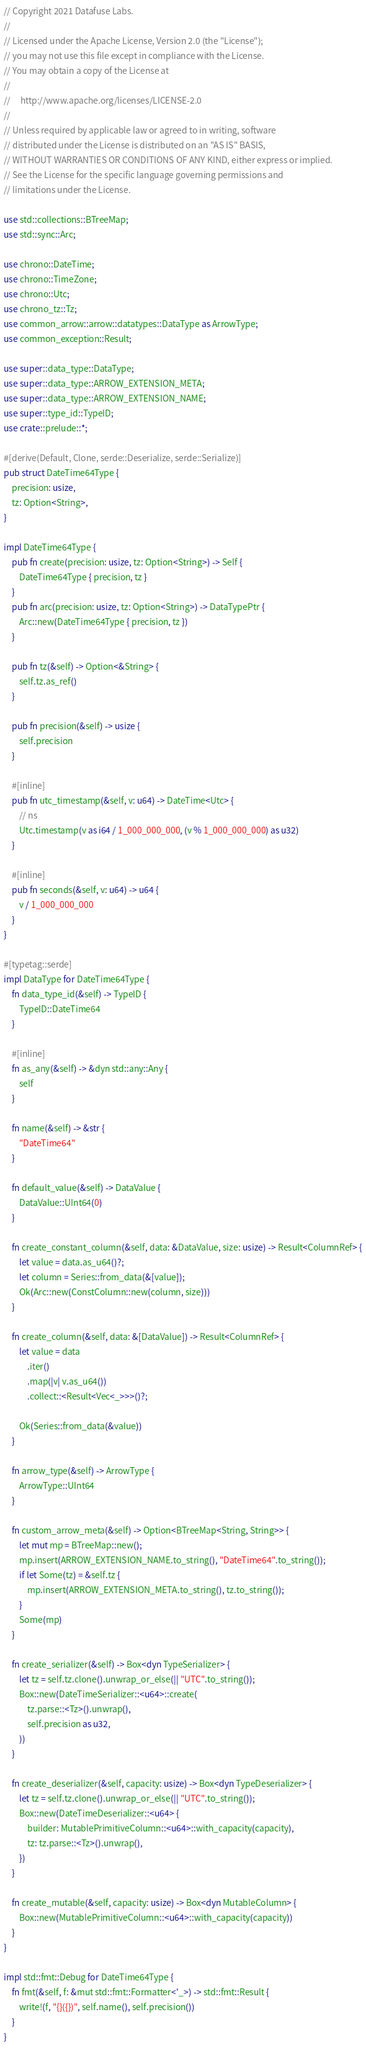<code> <loc_0><loc_0><loc_500><loc_500><_Rust_>// Copyright 2021 Datafuse Labs.
//
// Licensed under the Apache License, Version 2.0 (the "License");
// you may not use this file except in compliance with the License.
// You may obtain a copy of the License at
//
//     http://www.apache.org/licenses/LICENSE-2.0
//
// Unless required by applicable law or agreed to in writing, software
// distributed under the License is distributed on an "AS IS" BASIS,
// WITHOUT WARRANTIES OR CONDITIONS OF ANY KIND, either express or implied.
// See the License for the specific language governing permissions and
// limitations under the License.

use std::collections::BTreeMap;
use std::sync::Arc;

use chrono::DateTime;
use chrono::TimeZone;
use chrono::Utc;
use chrono_tz::Tz;
use common_arrow::arrow::datatypes::DataType as ArrowType;
use common_exception::Result;

use super::data_type::DataType;
use super::data_type::ARROW_EXTENSION_META;
use super::data_type::ARROW_EXTENSION_NAME;
use super::type_id::TypeID;
use crate::prelude::*;

#[derive(Default, Clone, serde::Deserialize, serde::Serialize)]
pub struct DateTime64Type {
    precision: usize,
    tz: Option<String>,
}

impl DateTime64Type {
    pub fn create(precision: usize, tz: Option<String>) -> Self {
        DateTime64Type { precision, tz }
    }
    pub fn arc(precision: usize, tz: Option<String>) -> DataTypePtr {
        Arc::new(DateTime64Type { precision, tz })
    }

    pub fn tz(&self) -> Option<&String> {
        self.tz.as_ref()
    }

    pub fn precision(&self) -> usize {
        self.precision
    }

    #[inline]
    pub fn utc_timestamp(&self, v: u64) -> DateTime<Utc> {
        // ns
        Utc.timestamp(v as i64 / 1_000_000_000, (v % 1_000_000_000) as u32)
    }

    #[inline]
    pub fn seconds(&self, v: u64) -> u64 {
        v / 1_000_000_000
    }
}

#[typetag::serde]
impl DataType for DateTime64Type {
    fn data_type_id(&self) -> TypeID {
        TypeID::DateTime64
    }

    #[inline]
    fn as_any(&self) -> &dyn std::any::Any {
        self
    }

    fn name(&self) -> &str {
        "DateTime64"
    }

    fn default_value(&self) -> DataValue {
        DataValue::UInt64(0)
    }

    fn create_constant_column(&self, data: &DataValue, size: usize) -> Result<ColumnRef> {
        let value = data.as_u64()?;
        let column = Series::from_data(&[value]);
        Ok(Arc::new(ConstColumn::new(column, size)))
    }

    fn create_column(&self, data: &[DataValue]) -> Result<ColumnRef> {
        let value = data
            .iter()
            .map(|v| v.as_u64())
            .collect::<Result<Vec<_>>>()?;

        Ok(Series::from_data(&value))
    }

    fn arrow_type(&self) -> ArrowType {
        ArrowType::UInt64
    }

    fn custom_arrow_meta(&self) -> Option<BTreeMap<String, String>> {
        let mut mp = BTreeMap::new();
        mp.insert(ARROW_EXTENSION_NAME.to_string(), "DateTime64".to_string());
        if let Some(tz) = &self.tz {
            mp.insert(ARROW_EXTENSION_META.to_string(), tz.to_string());
        }
        Some(mp)
    }

    fn create_serializer(&self) -> Box<dyn TypeSerializer> {
        let tz = self.tz.clone().unwrap_or_else(|| "UTC".to_string());
        Box::new(DateTimeSerializer::<u64>::create(
            tz.parse::<Tz>().unwrap(),
            self.precision as u32,
        ))
    }

    fn create_deserializer(&self, capacity: usize) -> Box<dyn TypeDeserializer> {
        let tz = self.tz.clone().unwrap_or_else(|| "UTC".to_string());
        Box::new(DateTimeDeserializer::<u64> {
            builder: MutablePrimitiveColumn::<u64>::with_capacity(capacity),
            tz: tz.parse::<Tz>().unwrap(),
        })
    }

    fn create_mutable(&self, capacity: usize) -> Box<dyn MutableColumn> {
        Box::new(MutablePrimitiveColumn::<u64>::with_capacity(capacity))
    }
}

impl std::fmt::Debug for DateTime64Type {
    fn fmt(&self, f: &mut std::fmt::Formatter<'_>) -> std::fmt::Result {
        write!(f, "{}({})", self.name(), self.precision())
    }
}
</code> 